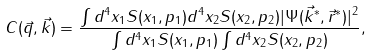<formula> <loc_0><loc_0><loc_500><loc_500>C ( { \vec { q } } , { \vec { k } } ) = \frac { \int d ^ { 4 } x _ { 1 } S ( x _ { 1 } , p _ { 1 } ) d ^ { 4 } x _ { 2 } S ( x _ { 2 } , p _ { 2 } ) | \Psi ( { \vec { k } } ^ { * } , { \vec { r } } ^ { * } ) | ^ { 2 } } { \int d ^ { 4 } x _ { 1 } S ( x _ { 1 } , p _ { 1 } ) \int d ^ { 4 } x _ { 2 } S ( x _ { 2 } , p _ { 2 } ) } ,</formula> 